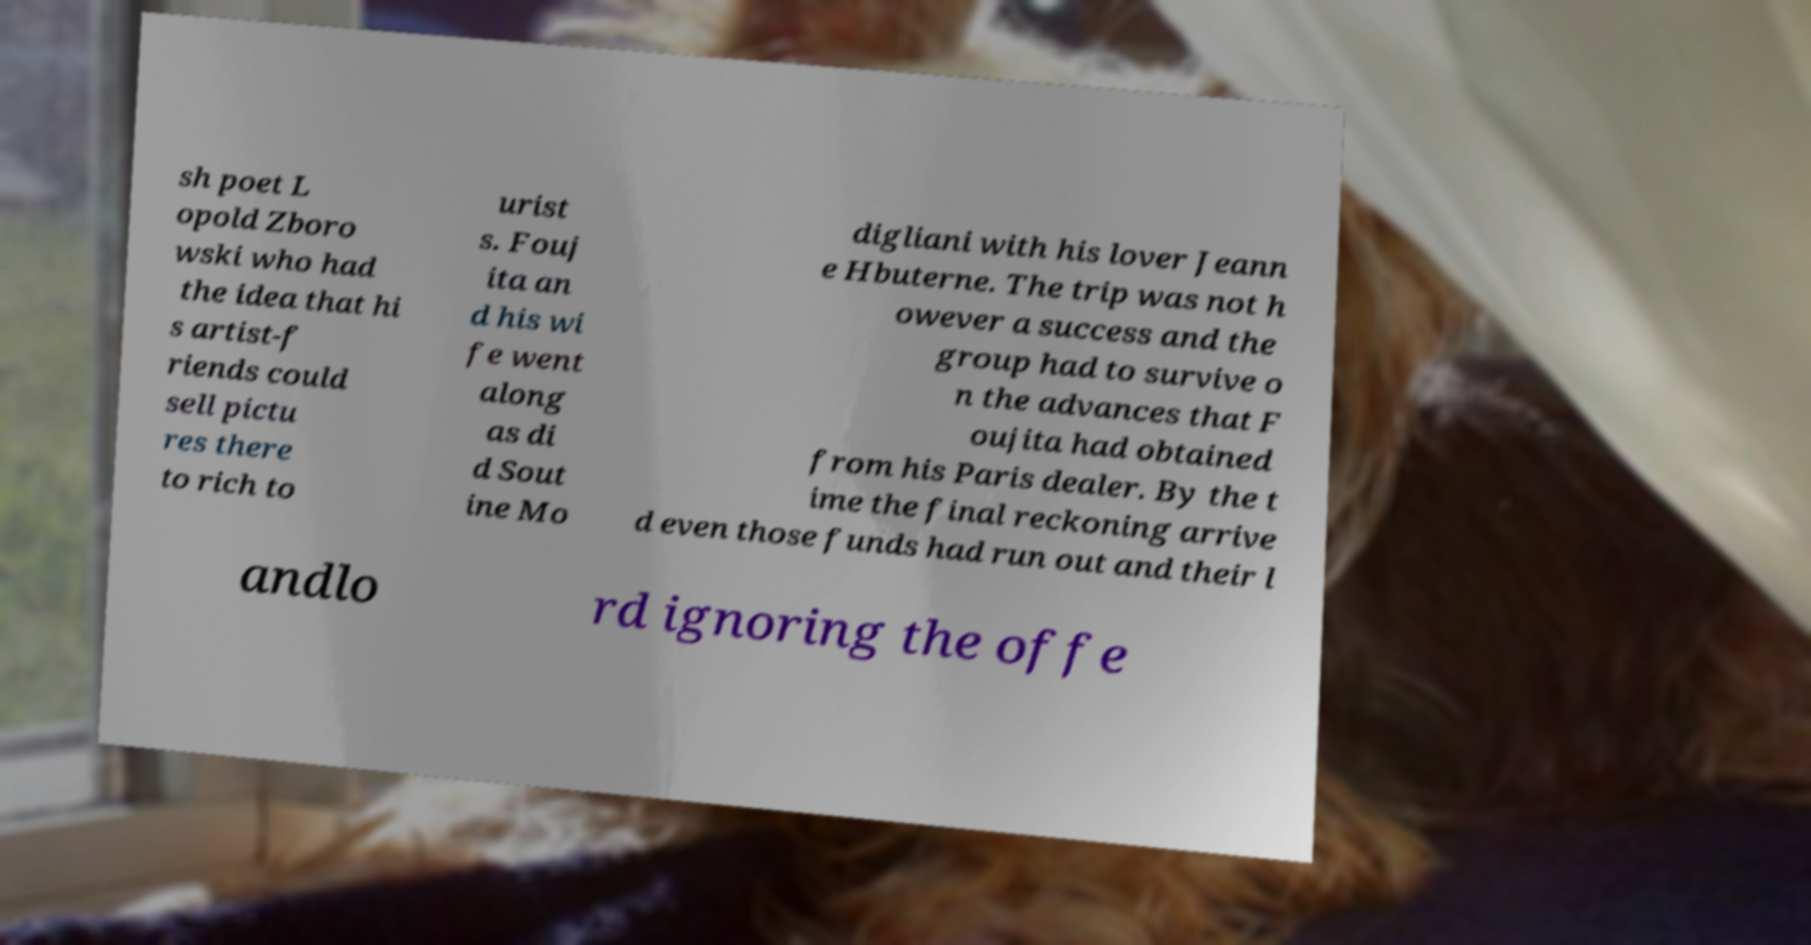Can you accurately transcribe the text from the provided image for me? sh poet L opold Zboro wski who had the idea that hi s artist-f riends could sell pictu res there to rich to urist s. Fouj ita an d his wi fe went along as di d Sout ine Mo digliani with his lover Jeann e Hbuterne. The trip was not h owever a success and the group had to survive o n the advances that F oujita had obtained from his Paris dealer. By the t ime the final reckoning arrive d even those funds had run out and their l andlo rd ignoring the offe 